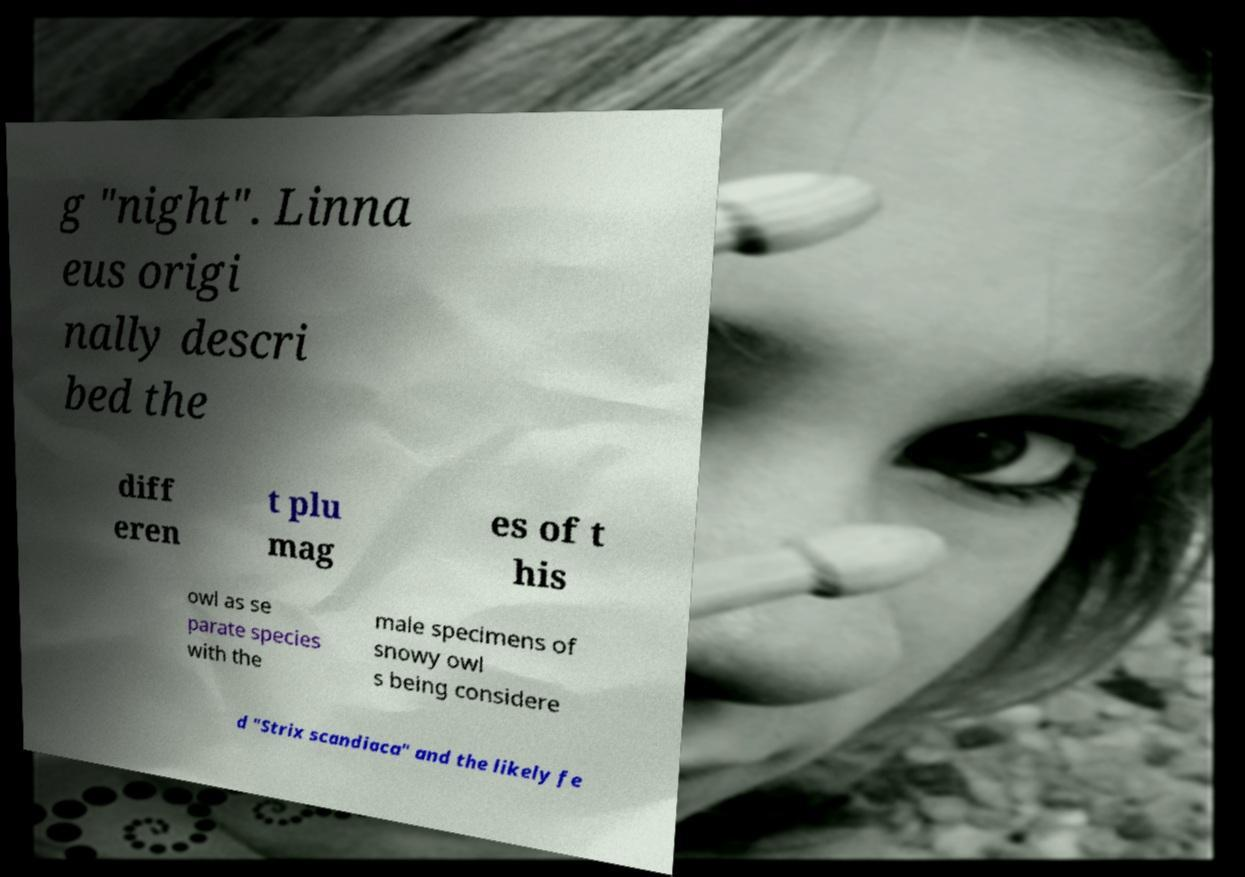Could you assist in decoding the text presented in this image and type it out clearly? g "night". Linna eus origi nally descri bed the diff eren t plu mag es of t his owl as se parate species with the male specimens of snowy owl s being considere d "Strix scandiaca" and the likely fe 